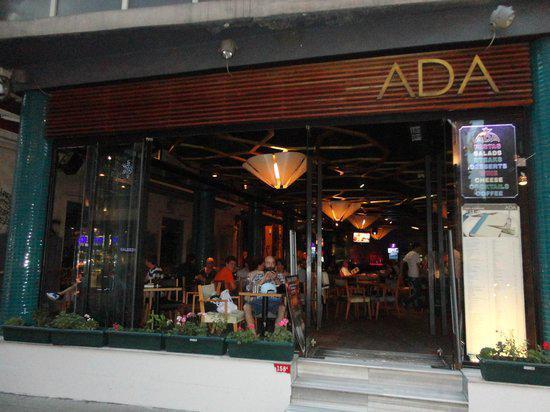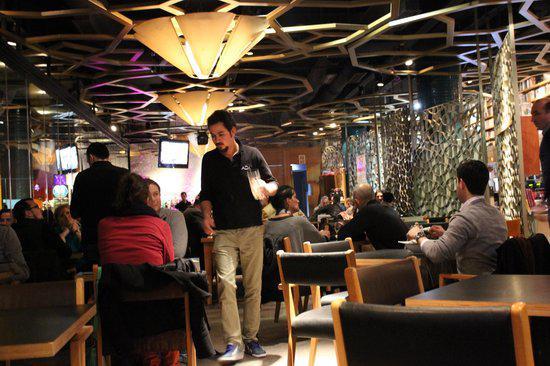The first image is the image on the left, the second image is the image on the right. Analyze the images presented: Is the assertion "In at least one image there is no more than one person in a wine and book shop." valid? Answer yes or no. No. The first image is the image on the left, the second image is the image on the right. For the images displayed, is the sentence "The right image shows the interior of a restaurant with cone-shaped light fixtures on a ceiling with suspended circles containing geometric patterns that repeat on the right wall." factually correct? Answer yes or no. Yes. 